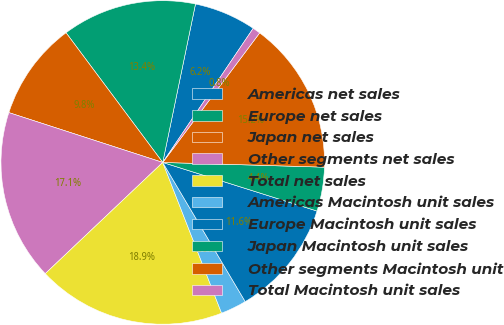<chart> <loc_0><loc_0><loc_500><loc_500><pie_chart><fcel>Americas net sales<fcel>Europe net sales<fcel>Japan net sales<fcel>Other segments net sales<fcel>Total net sales<fcel>Americas Macintosh unit sales<fcel>Europe Macintosh unit sales<fcel>Japan Macintosh unit sales<fcel>Other segments Macintosh unit<fcel>Total Macintosh unit sales<nl><fcel>6.2%<fcel>13.44%<fcel>9.82%<fcel>17.05%<fcel>18.86%<fcel>2.59%<fcel>11.63%<fcel>4.39%<fcel>15.24%<fcel>0.78%<nl></chart> 